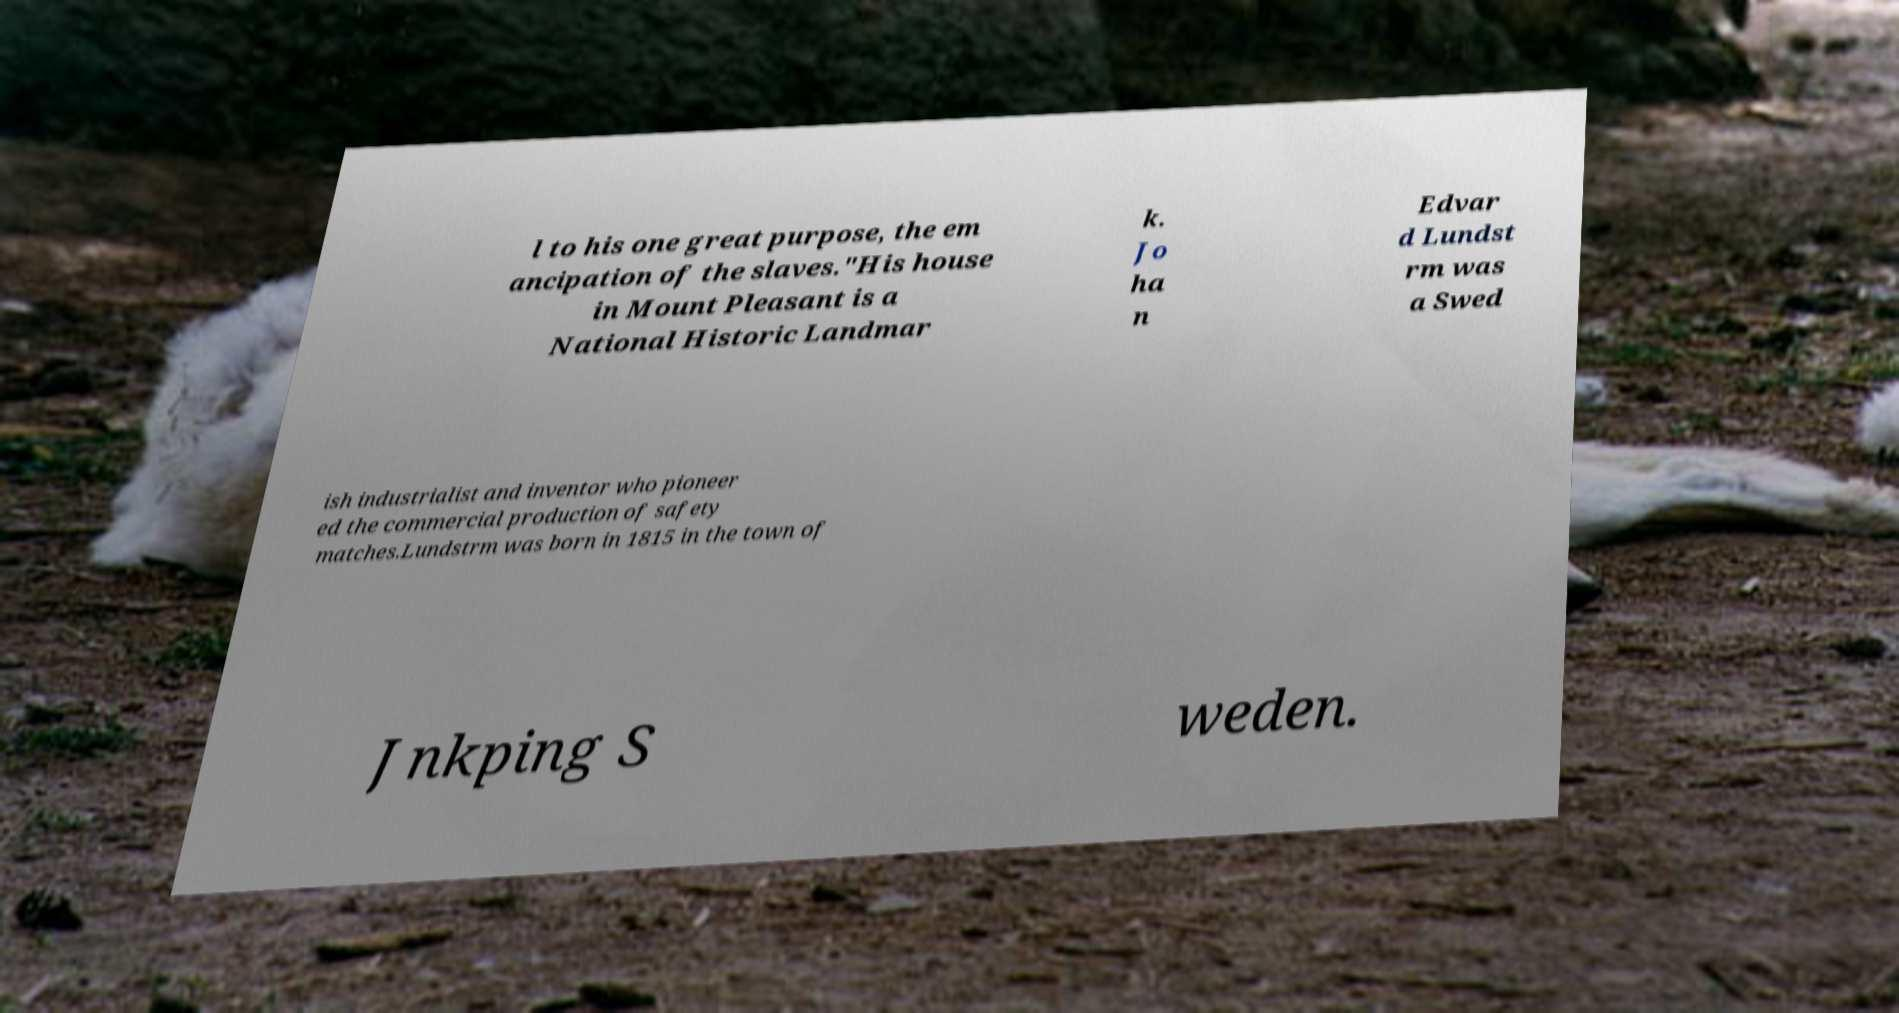Can you read and provide the text displayed in the image?This photo seems to have some interesting text. Can you extract and type it out for me? l to his one great purpose, the em ancipation of the slaves."His house in Mount Pleasant is a National Historic Landmar k. Jo ha n Edvar d Lundst rm was a Swed ish industrialist and inventor who pioneer ed the commercial production of safety matches.Lundstrm was born in 1815 in the town of Jnkping S weden. 